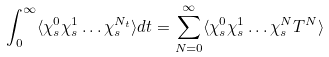Convert formula to latex. <formula><loc_0><loc_0><loc_500><loc_500>\int _ { 0 } ^ { \infty } \langle \chi ^ { 0 } _ { s } \chi ^ { 1 } _ { s } \dots \chi ^ { N _ { t } } _ { s } \rangle d t = \sum _ { N = 0 } ^ { \infty } \langle \chi ^ { 0 } _ { s } \chi ^ { 1 } _ { s } \dots \chi ^ { N } _ { s } T ^ { N } \rangle</formula> 